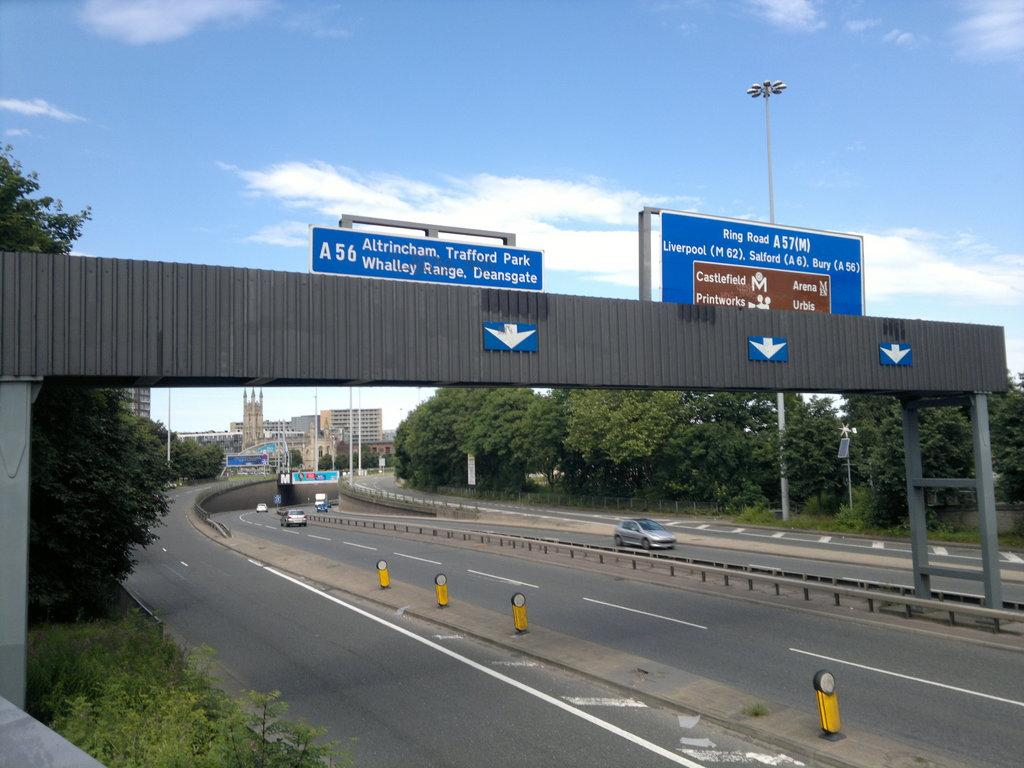<image>
Offer a succinct explanation of the picture presented. A highway has signs for cities such as Liverpool, Salford, and Bury. 